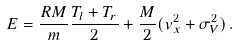<formula> <loc_0><loc_0><loc_500><loc_500>E = \frac { R M } { m } \frac { T _ { l } + T _ { r } } { 2 } + \frac { M } { 2 } ( v _ { x } ^ { 2 } + \sigma ^ { 2 } _ { V } ) \, .</formula> 